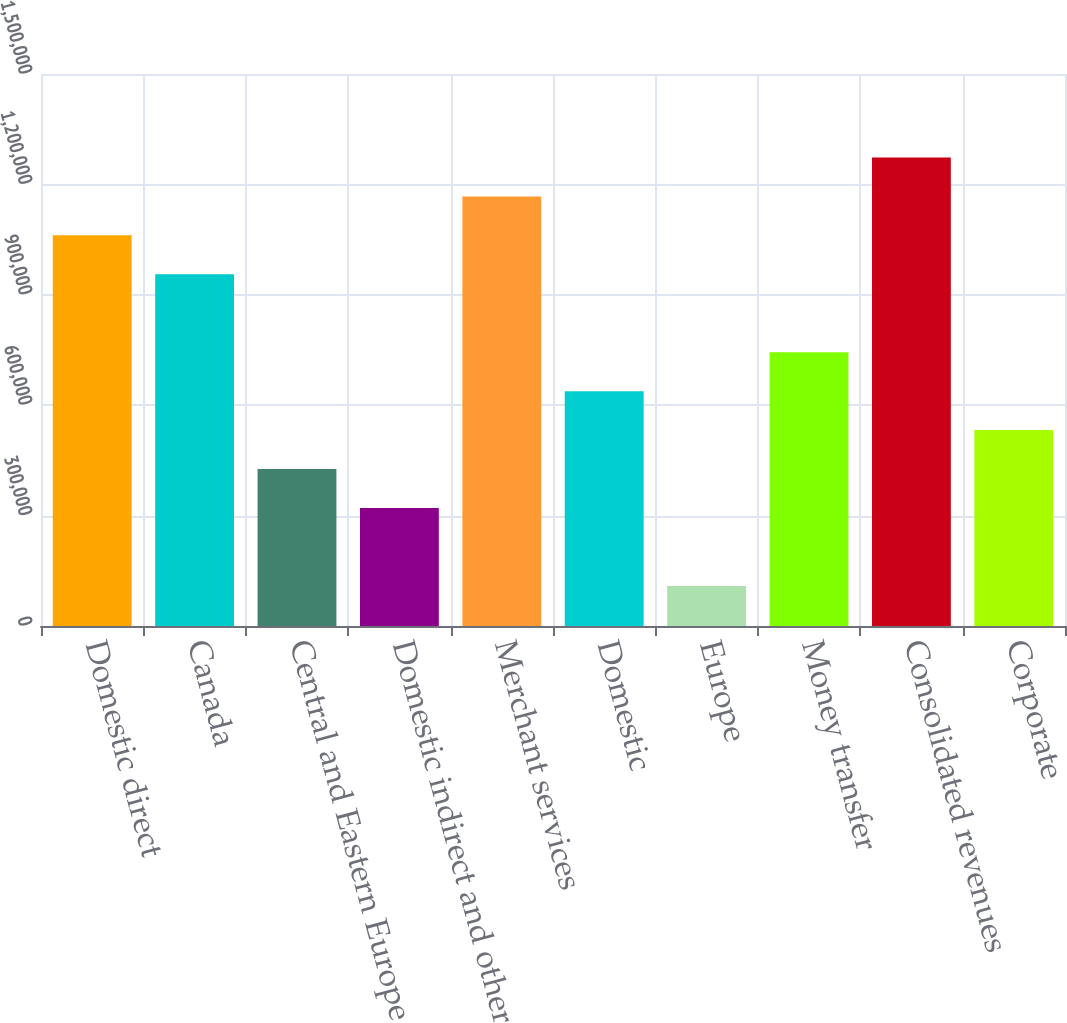Convert chart to OTSL. <chart><loc_0><loc_0><loc_500><loc_500><bar_chart><fcel>Domestic direct<fcel>Canada<fcel>Central and Eastern Europe<fcel>Domestic indirect and other<fcel>Merchant services<fcel>Domestic<fcel>Europe<fcel>Money transfer<fcel>Consolidated revenues<fcel>Corporate<nl><fcel>1.06152e+06<fcel>955680<fcel>426462<fcel>320618<fcel>1.16737e+06<fcel>638149<fcel>108932<fcel>743992<fcel>1.27321e+06<fcel>532306<nl></chart> 